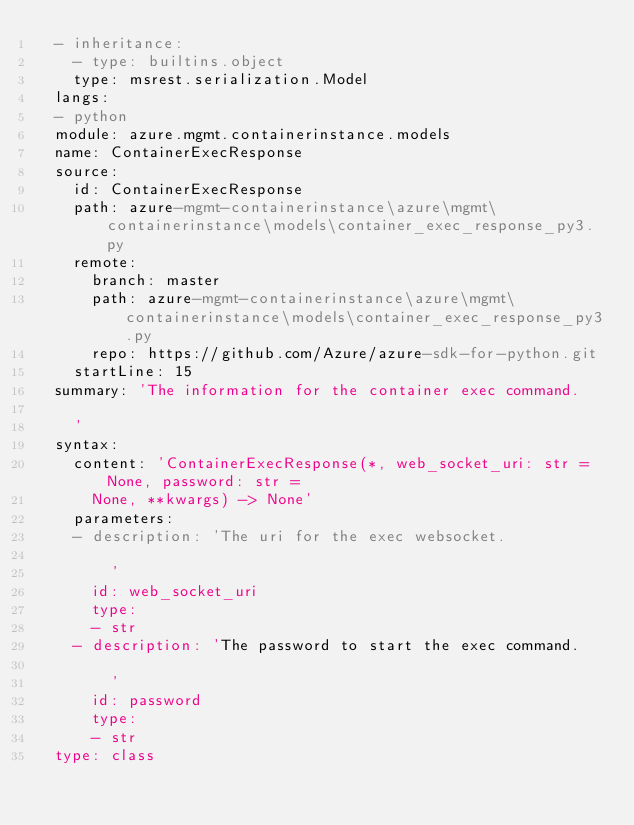<code> <loc_0><loc_0><loc_500><loc_500><_YAML_>  - inheritance:
    - type: builtins.object
    type: msrest.serialization.Model
  langs:
  - python
  module: azure.mgmt.containerinstance.models
  name: ContainerExecResponse
  source:
    id: ContainerExecResponse
    path: azure-mgmt-containerinstance\azure\mgmt\containerinstance\models\container_exec_response_py3.py
    remote:
      branch: master
      path: azure-mgmt-containerinstance\azure\mgmt\containerinstance\models\container_exec_response_py3.py
      repo: https://github.com/Azure/azure-sdk-for-python.git
    startLine: 15
  summary: 'The information for the container exec command.

    '
  syntax:
    content: 'ContainerExecResponse(*, web_socket_uri: str = None, password: str =
      None, **kwargs) -> None'
    parameters:
    - description: 'The uri for the exec websocket.

        '
      id: web_socket_uri
      type:
      - str
    - description: 'The password to start the exec command.

        '
      id: password
      type:
      - str
  type: class</code> 